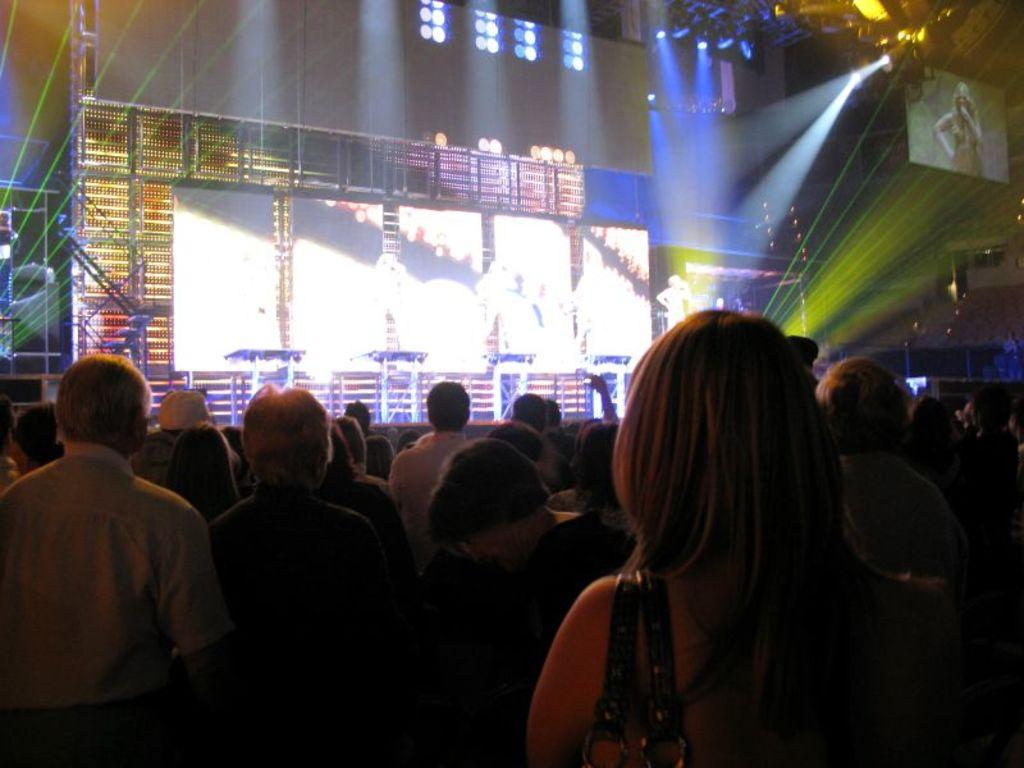What is happening in the image? There are people standing in the image. What can be seen in the background of the image? There are screens and lights in the background of the image. Can you describe the person visible in the background? There is a person visible in the background of the image. What type of snow can be seen falling in the image? There is no snow present in the image. Can you describe the smoke coming from the person's mouth in the image? There is no smoke coming from anyone's mouth in the image. 